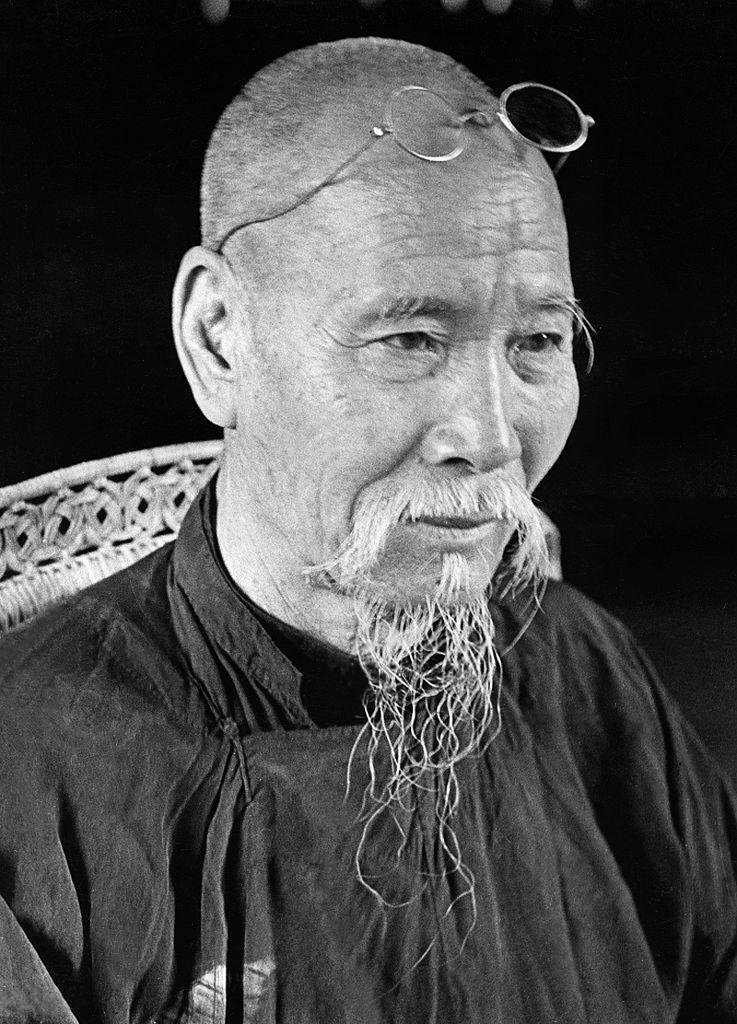What is the main subject of the image? There is a person in the image. What is the person doing in the image? The person is sitting on a chair. What can be observed about the background of the image? The background of the image is dark. What type of cloud can be seen on the side of the person in the image? There is no cloud visible in the image, and the person's side is not mentioned in the provided facts. 